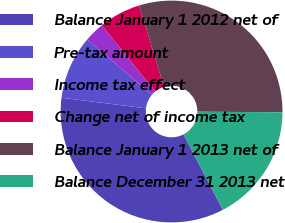Convert chart to OTSL. <chart><loc_0><loc_0><loc_500><loc_500><pie_chart><fcel>Balance January 1 2012 net of<fcel>Pre-tax amount<fcel>Income tax effect<fcel>Change net of income tax<fcel>Balance January 1 2013 net of<fcel>Balance December 31 2013 net<nl><fcel>34.62%<fcel>9.27%<fcel>2.93%<fcel>6.1%<fcel>29.84%<fcel>17.24%<nl></chart> 